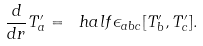Convert formula to latex. <formula><loc_0><loc_0><loc_500><loc_500>\frac { d } { d r } T _ { a } ^ { \prime } = \ h a l f \epsilon _ { a b c } [ T _ { b } ^ { \prime } , T _ { c } ^ { \prime } ] .</formula> 